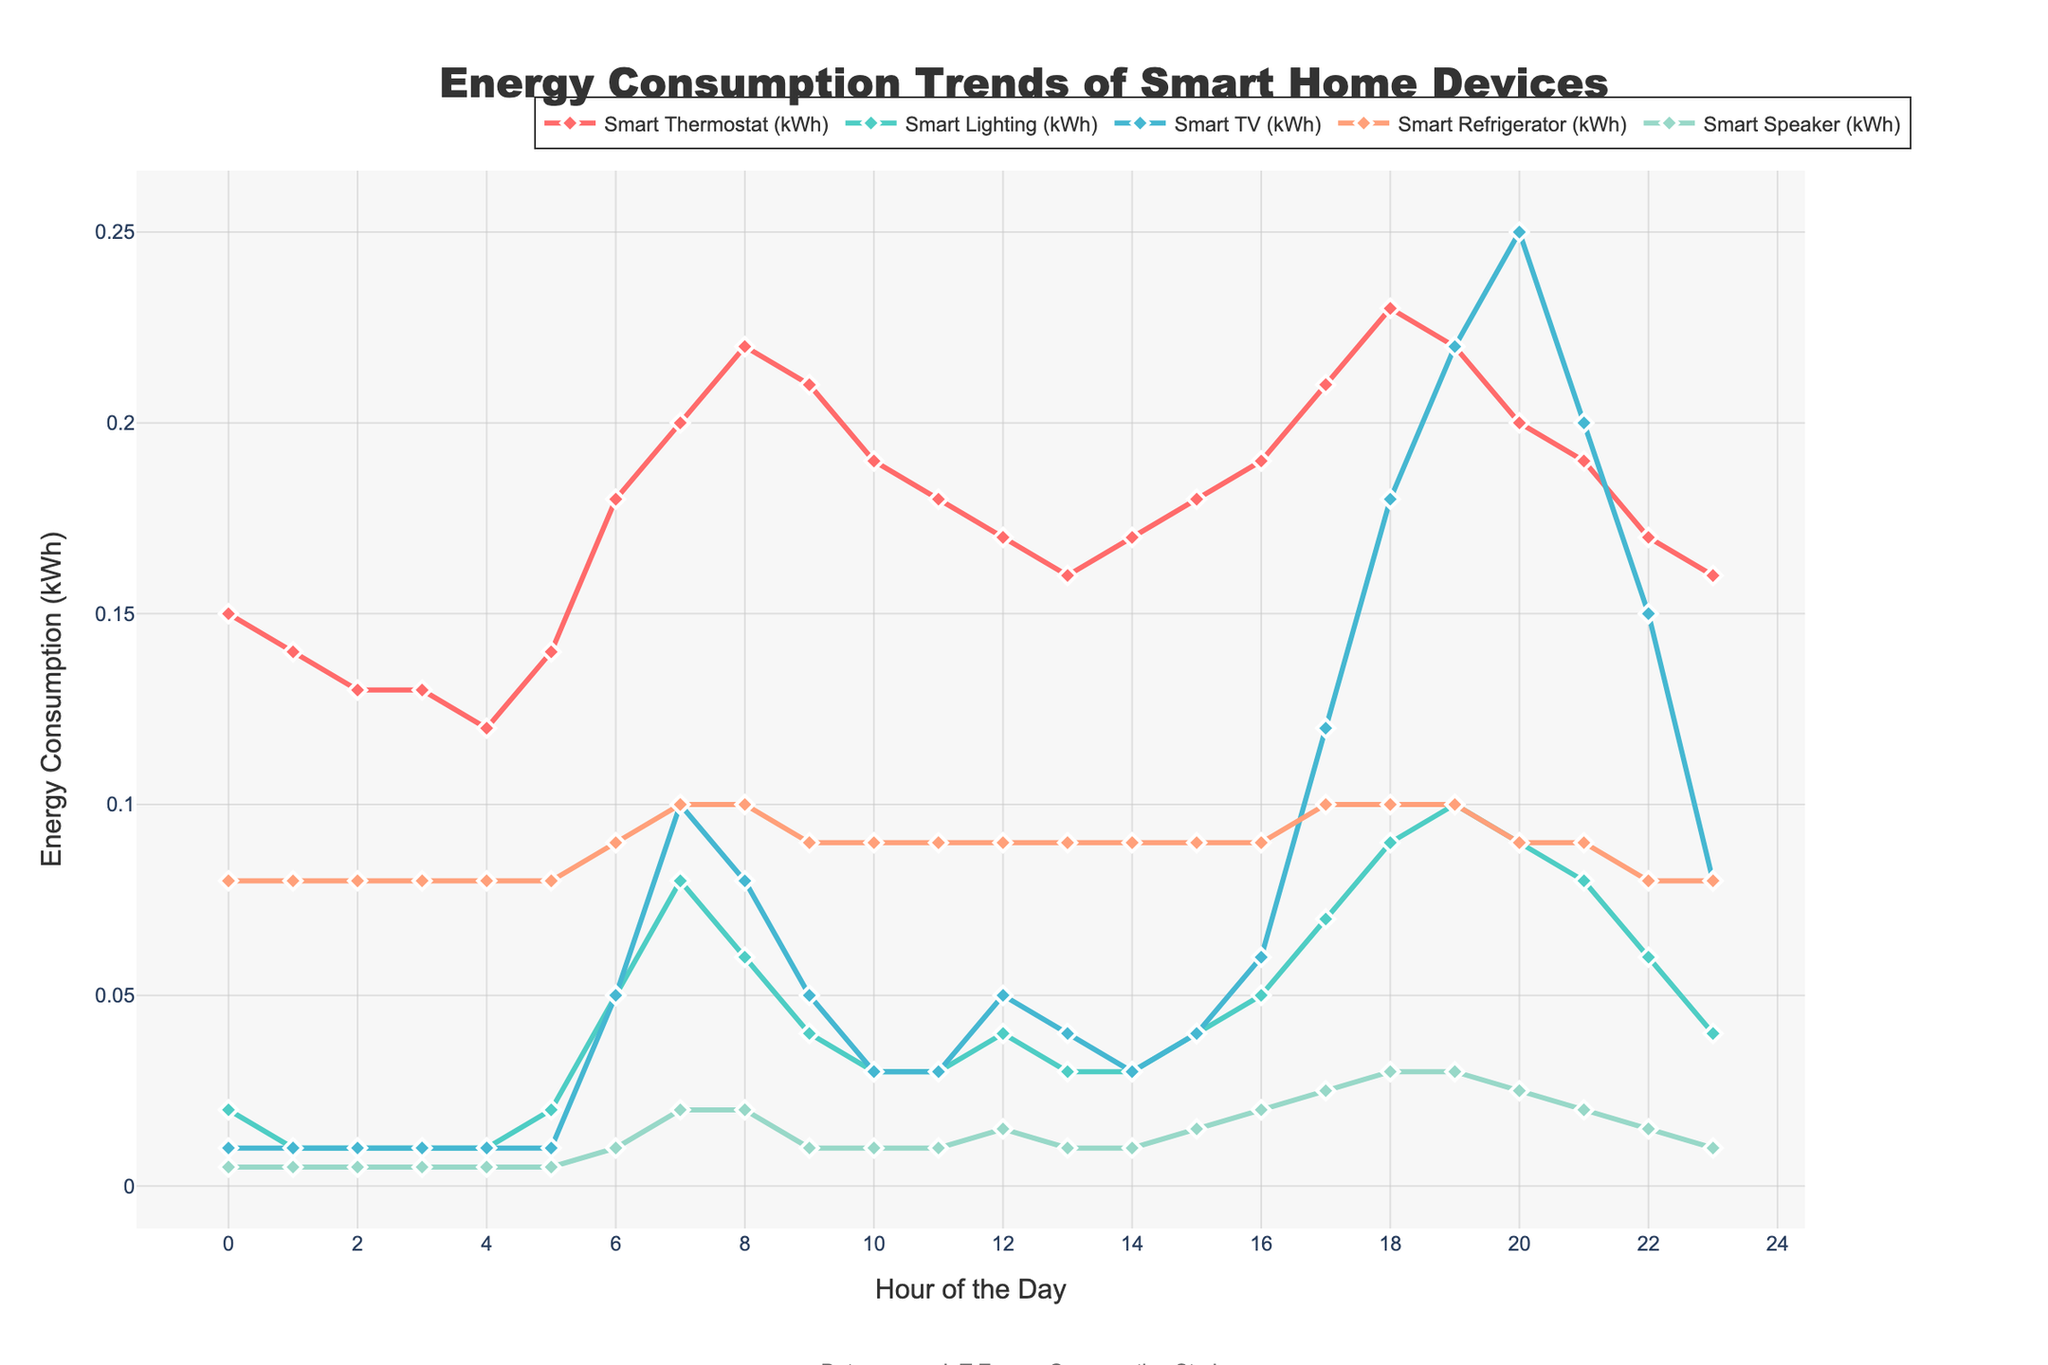What's the peak energy consumption of the Smart TV? To find the peak energy consumption of the Smart TV, locate the highest point on the line representing the Smart TV across the 24-hour period on the chart.
Answer: 0.25 kWh How does the energy consumption of the Smart Thermostat at 7 AM compare to its consumption at 7 PM? At 7 AM, the energy consumption is 0.20 kWh. At 7 PM, it is 0.22 kWh. Comparing these, the consumption at 7 PM is higher by 0.02 kWh.
Answer: 0.02 kWh higher at 7 PM What's the total energy consumption of Smart Lighting between 6 AM and 10 AM? Sum the energy consumption values of Smart Lighting from 6 AM to 10 AM: 0.05 + 0.08 + 0.06 + 0.04 + 0.03 = 0.26 kWh.
Answer: 0.26 kWh Which device has the most stable (least varying) energy consumption throughout the 24-hour period? Identify the device with the smallest range (max value - min value) in energy consumption. The Smart Refrigerator and Smart Speaker both have very stable, nearly constant consumptions of 0.08-0.10 kWh and 0.005-0.03 kWh, respectively. The Smart Speaker is more stable.
Answer: Smart Speaker What is the energy consumption difference between Smart Thermostat and Smart Refrigerator at 6 AM? At 6 AM, the Smart Thermostat consumes 0.18 kWh and the Smart Refrigerator consumes 0.09 kWh. The difference is 0.18 - 0.09 = 0.09 kWh.
Answer: 0.09 kWh Is there a time period where Smart TV's energy consumption exceeds that of Smart Thermostat? Compare the energy consumption of the Smart TV and Smart Thermostat across the 24-hour period. After 5 PM, the Smart TV's energy consumption exceeds the Smart Thermostat's consumption (e.g., at 7 PM, Smart TV: 0.22 kWh, Smart Thermostat: 0.20 kWh).
Answer: Yes, after 5 PM How does the energy consumption trend of Smart Lighting change from midnight to 6 AM? From midnight to 6 AM, Smart Lighting's energy consumption starts at 0.02 kWh, then decreases to 0.01 kWh, and increases slightly to 0.02 kWh at 5 AM and significantly to 0.05 kWh at 6 AM. Overall, there is a decrease and then a rise.
Answer: Decrease, then rise What's the average energy consumption of the Smart Speaker over the entire 24-hour period? Sum the energy consumption values of the Smart Speaker and divide by 24: (0.005 + 0.005 + 0.005 + 0.005 + 0.005 + 0.005 + 0.01 + 0.02 + 0.02 + 0.01 + 0.01 + 0.01 + 0.015 + 0.01 + 0.01 + 0.015 + 0.02 + 0.025 + 0.03 + 0.03 + 0.025 + 0.02 + 0.015 + 0.01) / 24 = 0.0125 kWh.
Answer: 0.0125 kWh 